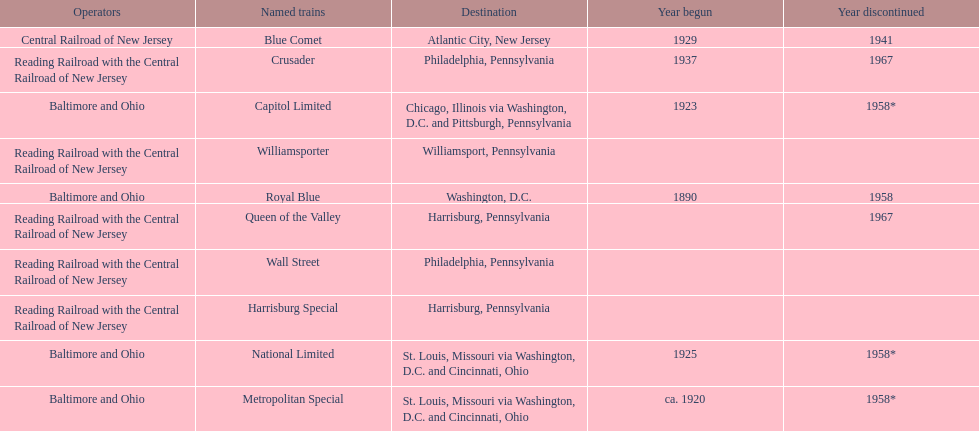What is the difference (in years) between when the royal blue began and the year the crusader began? 47. 